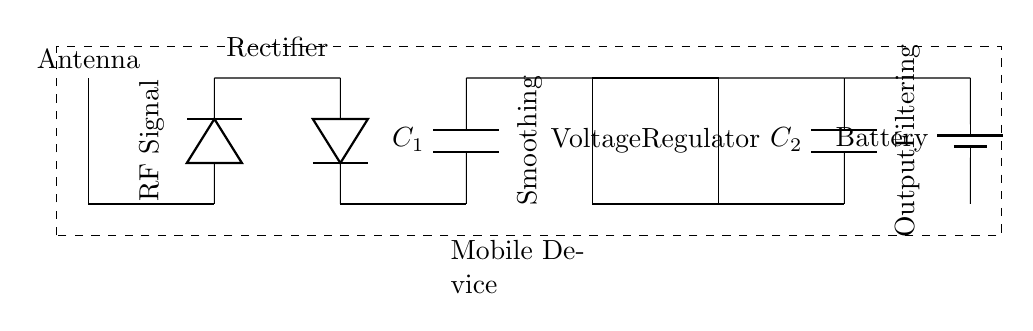What components are present in this circuit? The components are an antenna, two diodes, two capacitors, a voltage regulator, and a battery. Each component serves a specific purpose within the wireless charging receiver circuit.
Answer: antenna, diodes, capacitors, voltage regulator, battery What is the function of the antenna in this circuit? The antenna captures the RF signal, which is the initial step in the wireless charging process. It converts the RF energy into electrical energy for further processing in the circuit.
Answer: RF energy conversion How many diodes are in this circuit? There are two diodes present, which are used for rectification to convert alternating current from the RF signal into direct current suitable for charging the battery.
Answer: two What is the role of the voltage regulator? The voltage regulator ensures that the output voltage remains stable and within the required range for charging the battery, protecting it from voltage fluctuations.
Answer: voltage stabilization What happens to the RF signal after it is captured by the antenna? The RF signal is rectified by the diodes, which convert it into a direct current. This is followed by smoothing and filtering through the capacitors and voltage regulator for battery charging.
Answer: it is rectified to direct current What are the values of the capacitors labeled in the circuit? The circuit diagram labels the capacitors as C1 and C2. The specific numeric values may vary, but they are essential for smoothing and filtering the output current for the battery.
Answer: C1 and C2 What type of battery is shown in this circuit? The circuit diagram shows a generic battery symbol which typically represents a rechargeable lithium-ion battery used commonly in mobile devices for energy storage.
Answer: rechargeable lithium-ion battery 